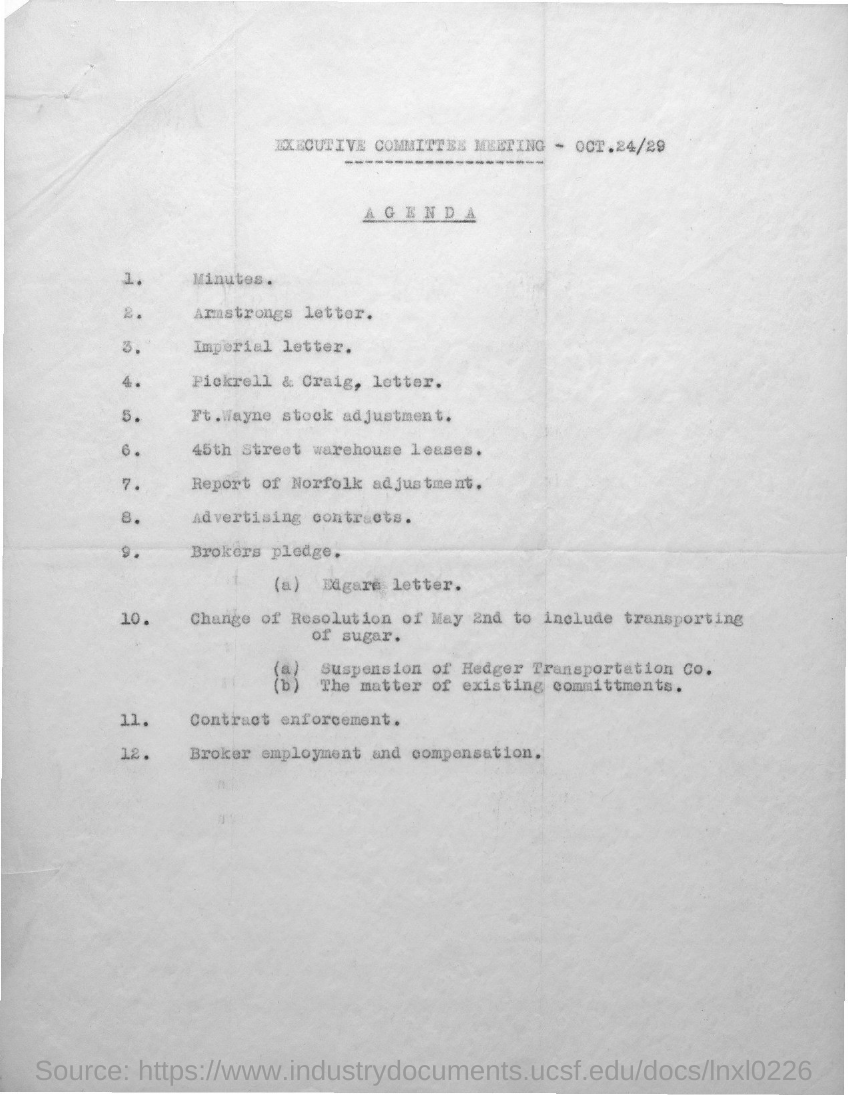When is the executive committee meeting held?
Your answer should be very brief. OCT.24/29. 